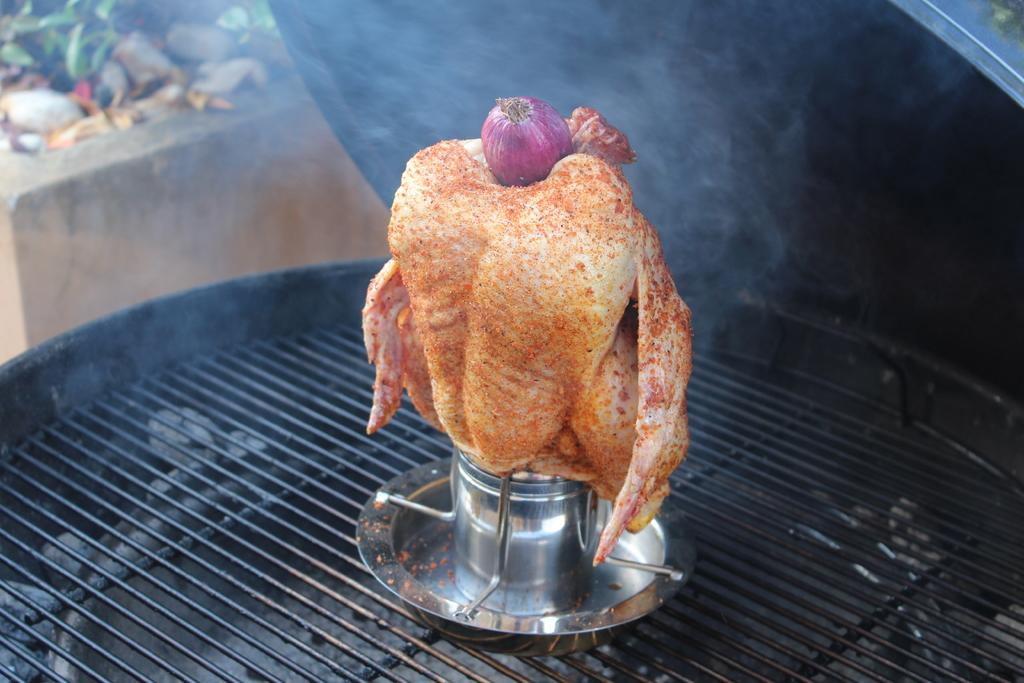What type of cooking equipment can be seen in the image? There are grills in the image. What type of vegetable is visible in the image? An onion is visible in the image. What is the result of the cooking process in the image? There is smoke in the image. What type of food is being cooked on the grills? Meat is present in the image. What type of lock is being used to secure the grills in the image? There is no lock present in the image; the grills are not secured. 